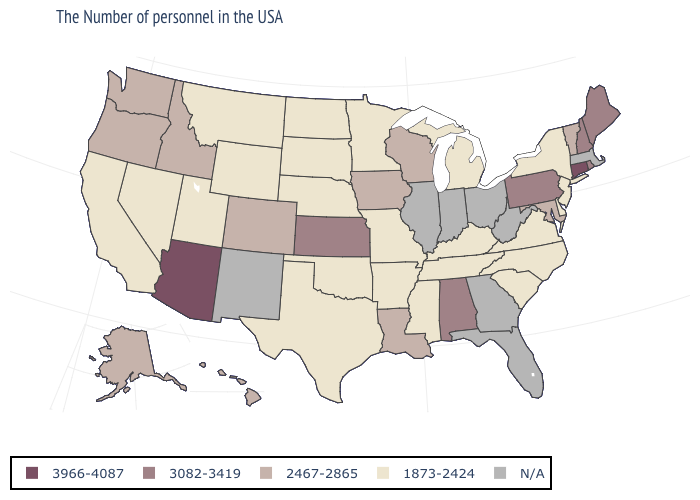Name the states that have a value in the range 3966-4087?
Give a very brief answer. Connecticut, Arizona. Which states have the highest value in the USA?
Answer briefly. Connecticut, Arizona. What is the value of Nebraska?
Answer briefly. 1873-2424. Among the states that border Oregon , which have the lowest value?
Write a very short answer. Nevada, California. What is the value of Illinois?
Short answer required. N/A. Does Connecticut have the lowest value in the Northeast?
Short answer required. No. What is the value of West Virginia?
Quick response, please. N/A. Which states have the highest value in the USA?
Quick response, please. Connecticut, Arizona. What is the value of Arkansas?
Quick response, please. 1873-2424. Does Connecticut have the highest value in the USA?
Be succinct. Yes. Among the states that border Oklahoma , which have the lowest value?
Be succinct. Missouri, Arkansas, Texas. What is the value of North Carolina?
Keep it brief. 1873-2424. What is the value of Tennessee?
Keep it brief. 1873-2424. 